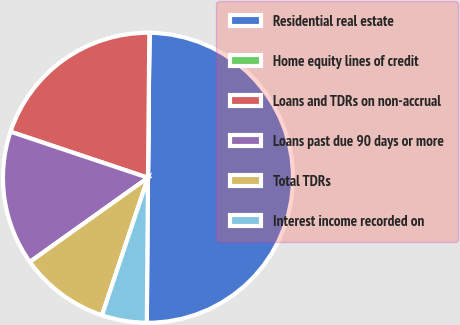Convert chart to OTSL. <chart><loc_0><loc_0><loc_500><loc_500><pie_chart><fcel>Residential real estate<fcel>Home equity lines of credit<fcel>Loans and TDRs on non-accrual<fcel>Loans past due 90 days or more<fcel>Total TDRs<fcel>Interest income recorded on<nl><fcel>49.96%<fcel>0.02%<fcel>20.0%<fcel>15.0%<fcel>10.01%<fcel>5.01%<nl></chart> 